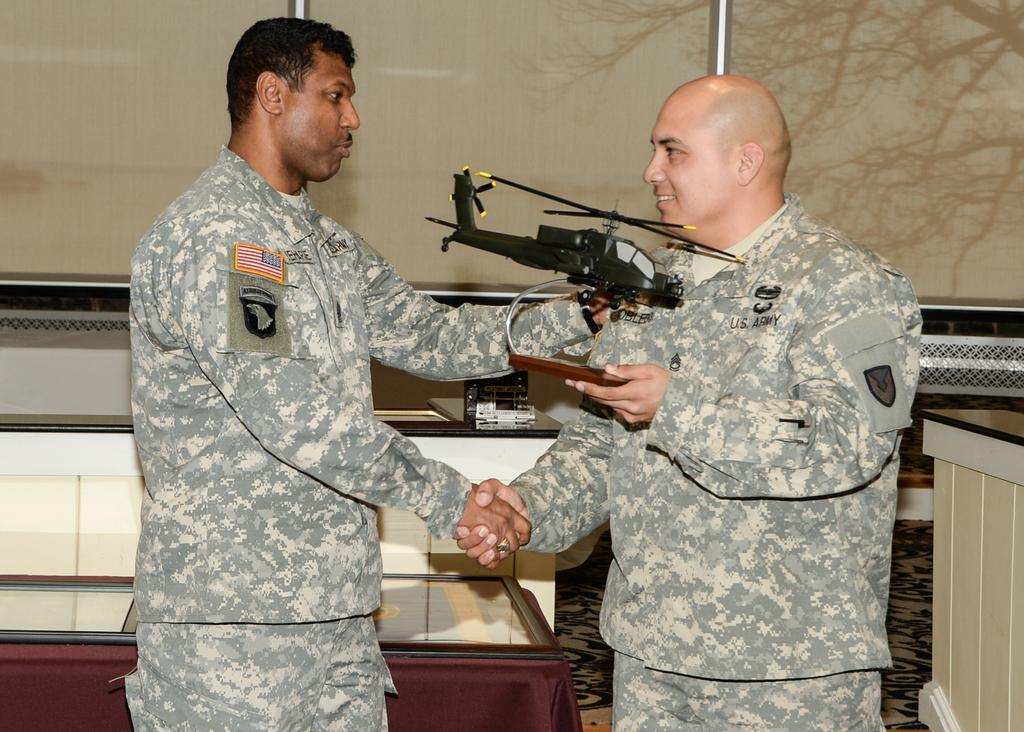How many people are in the image? There are two men in the image. What are the men doing in the image? The men are shaking hands in the image. What object is one of the men holding? One man is holding a helicopter toy in his hand. What can be seen in the background of the image? There is a wall in the background of the image. How many lizards are crawling on the wall in the image? There are no lizards present in the image; only the two men and the helicopter toy are visible. 